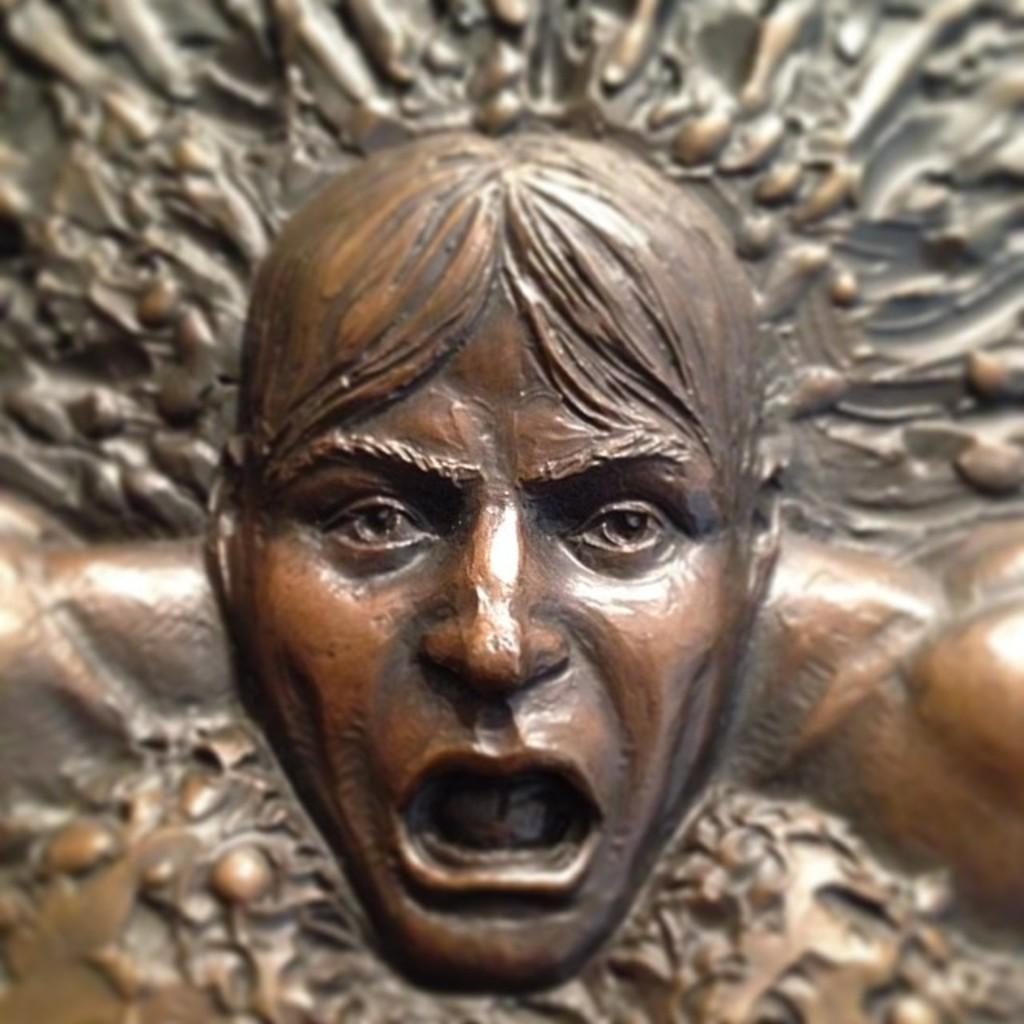What type of material is the human face carving made of in the image? The human face carving is made of metal in the image. Are there any other carvings present in the image? Yes, there are a few other carvings in the image. What type of flame can be seen coming from the carvings in the image? There is no flame present in the image; it features carvings on metal. How many girls are depicted in the carvings in the image? There are no girls depicted in the carvings in the image. 